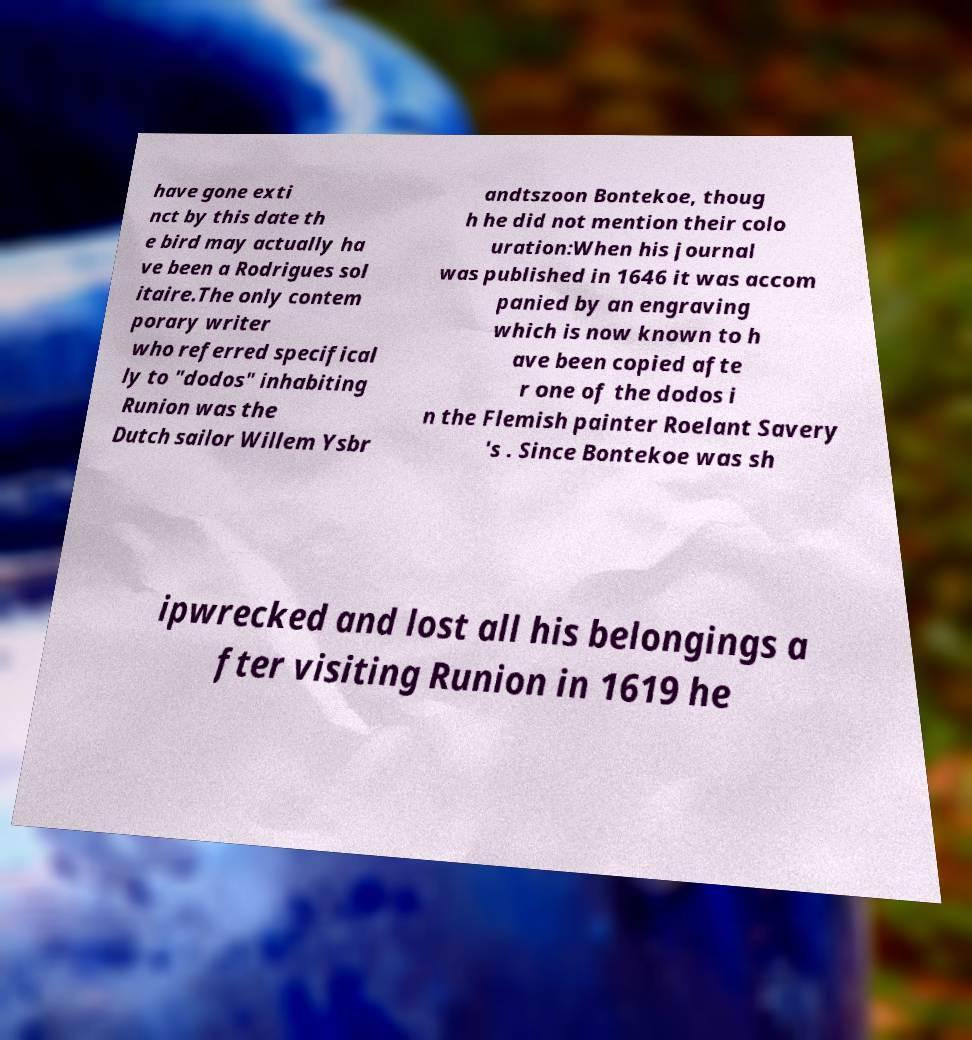I need the written content from this picture converted into text. Can you do that? have gone exti nct by this date th e bird may actually ha ve been a Rodrigues sol itaire.The only contem porary writer who referred specifical ly to "dodos" inhabiting Runion was the Dutch sailor Willem Ysbr andtszoon Bontekoe, thoug h he did not mention their colo uration:When his journal was published in 1646 it was accom panied by an engraving which is now known to h ave been copied afte r one of the dodos i n the Flemish painter Roelant Savery 's . Since Bontekoe was sh ipwrecked and lost all his belongings a fter visiting Runion in 1619 he 